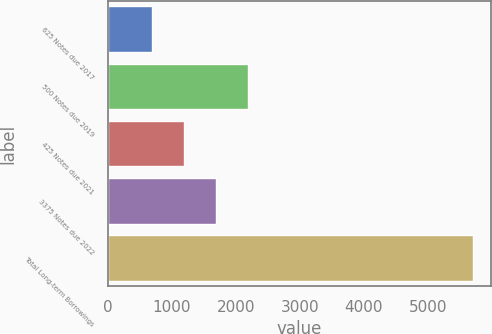Convert chart to OTSL. <chart><loc_0><loc_0><loc_500><loc_500><bar_chart><fcel>625 Notes due 2017<fcel>500 Notes due 2019<fcel>425 Notes due 2021<fcel>3375 Notes due 2022<fcel>Total Long-term Borrowings<nl><fcel>700<fcel>2200<fcel>1200<fcel>1700<fcel>5700<nl></chart> 